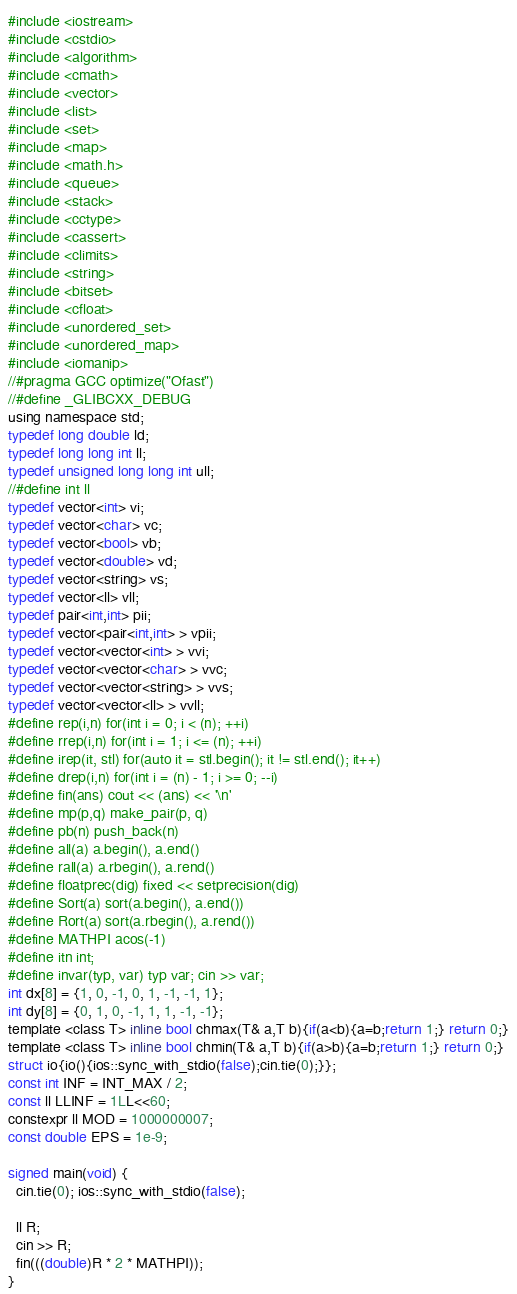Convert code to text. <code><loc_0><loc_0><loc_500><loc_500><_C_>#include <iostream>
#include <cstdio>
#include <algorithm>
#include <cmath>
#include <vector>
#include <list>
#include <set>
#include <map>
#include <math.h>
#include <queue>
#include <stack>
#include <cctype>
#include <cassert>
#include <climits>
#include <string>
#include <bitset>
#include <cfloat>
#include <unordered_set>
#include <unordered_map>
#include <iomanip>
//#pragma GCC optimize("Ofast")
//#define _GLIBCXX_DEBUG
using namespace std;
typedef long double ld;
typedef long long int ll;
typedef unsigned long long int ull;
//#define int ll
typedef vector<int> vi;
typedef vector<char> vc;
typedef vector<bool> vb;
typedef vector<double> vd;
typedef vector<string> vs;
typedef vector<ll> vll;
typedef pair<int,int> pii;
typedef vector<pair<int,int> > vpii;
typedef vector<vector<int> > vvi;
typedef vector<vector<char> > vvc;
typedef vector<vector<string> > vvs;
typedef vector<vector<ll> > vvll;
#define rep(i,n) for(int i = 0; i < (n); ++i)
#define rrep(i,n) for(int i = 1; i <= (n); ++i)
#define irep(it, stl) for(auto it = stl.begin(); it != stl.end(); it++)
#define drep(i,n) for(int i = (n) - 1; i >= 0; --i)
#define fin(ans) cout << (ans) << '\n'
#define mp(p,q) make_pair(p, q)
#define pb(n) push_back(n)
#define all(a) a.begin(), a.end()
#define rall(a) a.rbegin(), a.rend()
#define floatprec(dig) fixed << setprecision(dig)
#define Sort(a) sort(a.begin(), a.end())
#define Rort(a) sort(a.rbegin(), a.rend())
#define MATHPI acos(-1)
#define itn int;
#define invar(typ, var) typ var; cin >> var;
int dx[8] = {1, 0, -1, 0, 1, -1, -1, 1};
int dy[8] = {0, 1, 0, -1, 1, 1, -1, -1};
template <class T> inline bool chmax(T& a,T b){if(a<b){a=b;return 1;} return 0;}
template <class T> inline bool chmin(T& a,T b){if(a>b){a=b;return 1;} return 0;}
struct io{io(){ios::sync_with_stdio(false);cin.tie(0);}};
const int INF = INT_MAX / 2;
const ll LLINF = 1LL<<60;
constexpr ll MOD = 1000000007;
const double EPS = 1e-9;

signed main(void) {
  cin.tie(0); ios::sync_with_stdio(false);
  
  ll R;
  cin >> R;
  fin(((double)R * 2 * MATHPI));
}</code> 